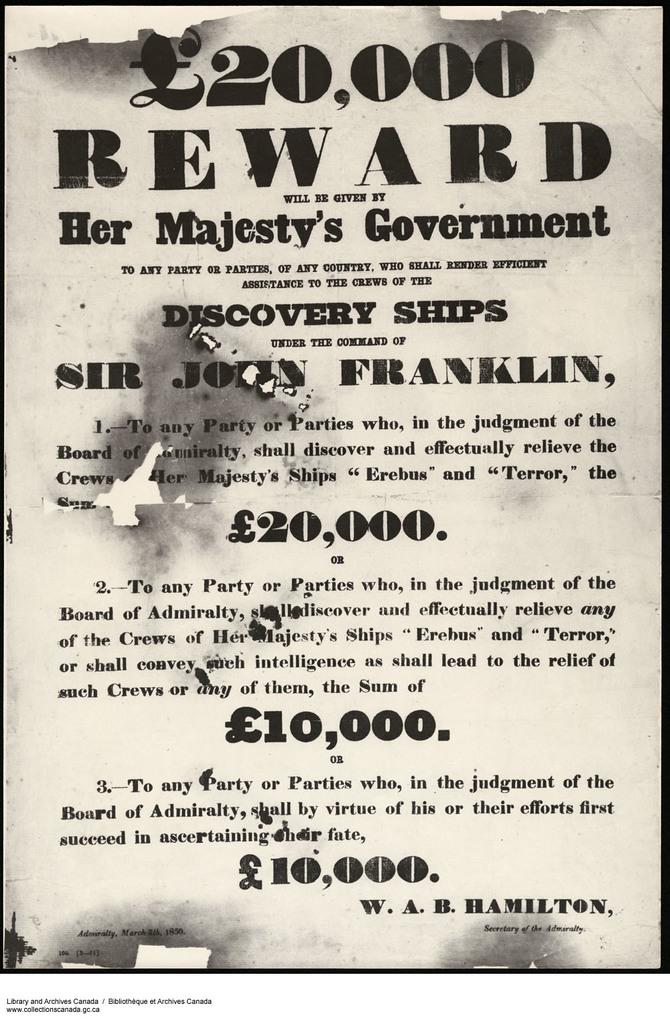<image>
Present a compact description of the photo's key features. A wanted poster for Sir John Franklin with a 20,000 Euro award to any person that finds him. 